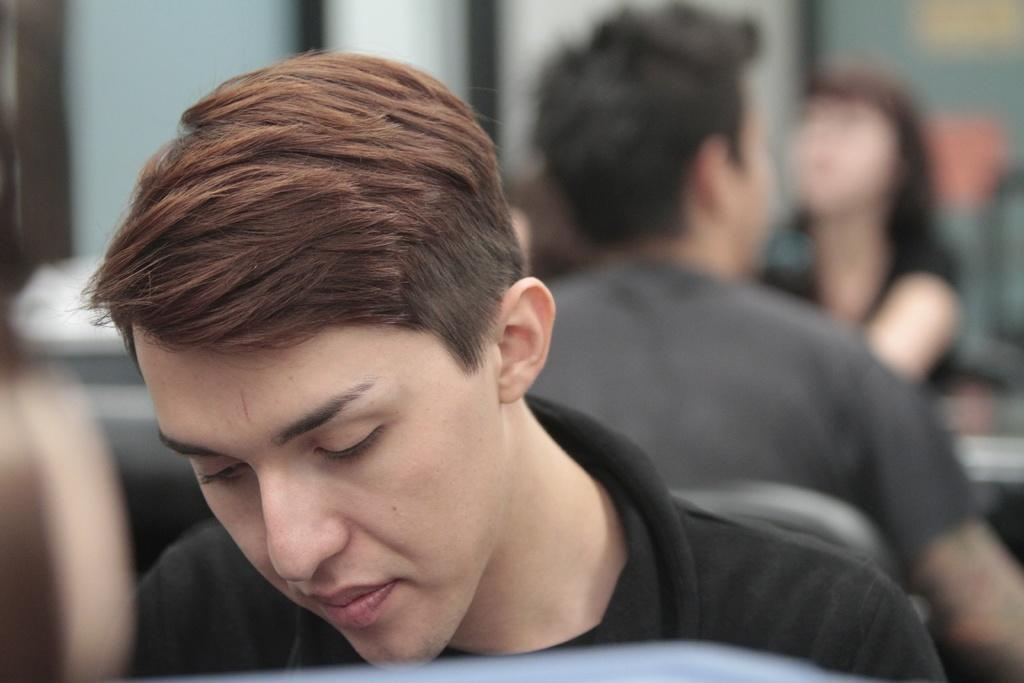How many people are in the image? There are three people in the image: two men and one woman. What are the men doing in the image? The men are seated on chairs, and they are seated behind each other. Can you describe the woman's position in the image? The woman is seated on a chair, and she is seated in front of one of the men. What type of popcorn is being shared by the cattle in the crowd in the image? There is no popcorn, cattle, or crowd present in the image. 